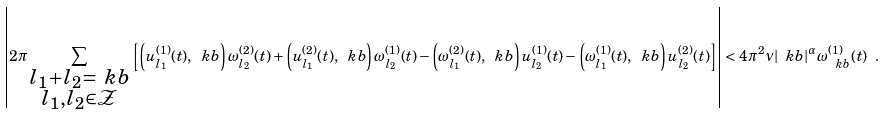<formula> <loc_0><loc_0><loc_500><loc_500>\left | 2 \pi \sum _ { \substack { l _ { 1 } + l _ { 2 } = \ k b \\ l _ { 1 } , l _ { 2 } \in \mathcal { Z } } } \left [ \left ( u ^ { ( 1 ) } _ { l _ { 1 } } ( t ) , \ k b \right ) \omega ^ { ( 2 ) } _ { l _ { 2 } } ( t ) + \left ( u ^ { ( 2 ) } _ { l _ { 1 } } ( t ) , \ k b \right ) \omega ^ { ( 1 ) } _ { l _ { 2 } } ( t ) - \left ( \omega ^ { ( 2 ) } _ { l _ { 1 } } ( t ) , \ k b \right ) u ^ { ( 1 ) } _ { l _ { 2 } } ( t ) - \left ( \omega ^ { ( 1 ) } _ { l _ { 1 } } ( t ) , \ k b \right ) u ^ { ( 2 ) } _ { l _ { 2 } } ( t ) \right ] \right | < 4 \pi ^ { 2 } \nu | \ k b | ^ { \alpha } \omega _ { \ k b } ^ { ( 1 ) } ( t ) \ .</formula> 